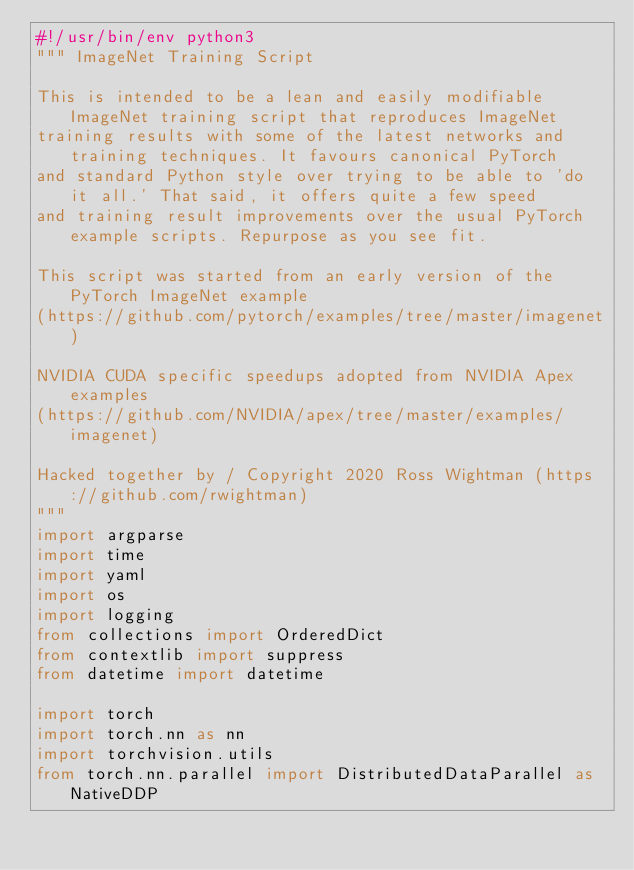<code> <loc_0><loc_0><loc_500><loc_500><_Python_>#!/usr/bin/env python3
""" ImageNet Training Script

This is intended to be a lean and easily modifiable ImageNet training script that reproduces ImageNet
training results with some of the latest networks and training techniques. It favours canonical PyTorch
and standard Python style over trying to be able to 'do it all.' That said, it offers quite a few speed
and training result improvements over the usual PyTorch example scripts. Repurpose as you see fit.

This script was started from an early version of the PyTorch ImageNet example
(https://github.com/pytorch/examples/tree/master/imagenet)

NVIDIA CUDA specific speedups adopted from NVIDIA Apex examples
(https://github.com/NVIDIA/apex/tree/master/examples/imagenet)

Hacked together by / Copyright 2020 Ross Wightman (https://github.com/rwightman)
"""
import argparse
import time
import yaml
import os
import logging
from collections import OrderedDict
from contextlib import suppress
from datetime import datetime

import torch
import torch.nn as nn
import torchvision.utils
from torch.nn.parallel import DistributedDataParallel as NativeDDP
</code> 